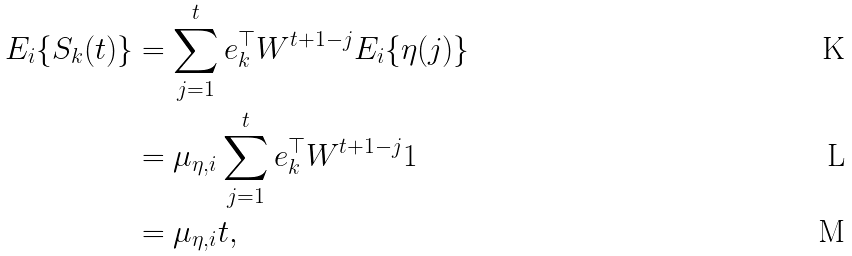Convert formula to latex. <formula><loc_0><loc_0><loc_500><loc_500>E _ { i } \{ S _ { k } ( t ) \} & = \sum _ { j = 1 } ^ { t } e _ { k } ^ { \top } W ^ { t + 1 - j } E _ { i } \{ \eta ( j ) \} \\ & = \mu _ { \eta , i } \sum _ { j = 1 } ^ { t } e _ { k } ^ { \top } W ^ { t + 1 - j } 1 \\ & = \mu _ { \eta , i } t ,</formula> 